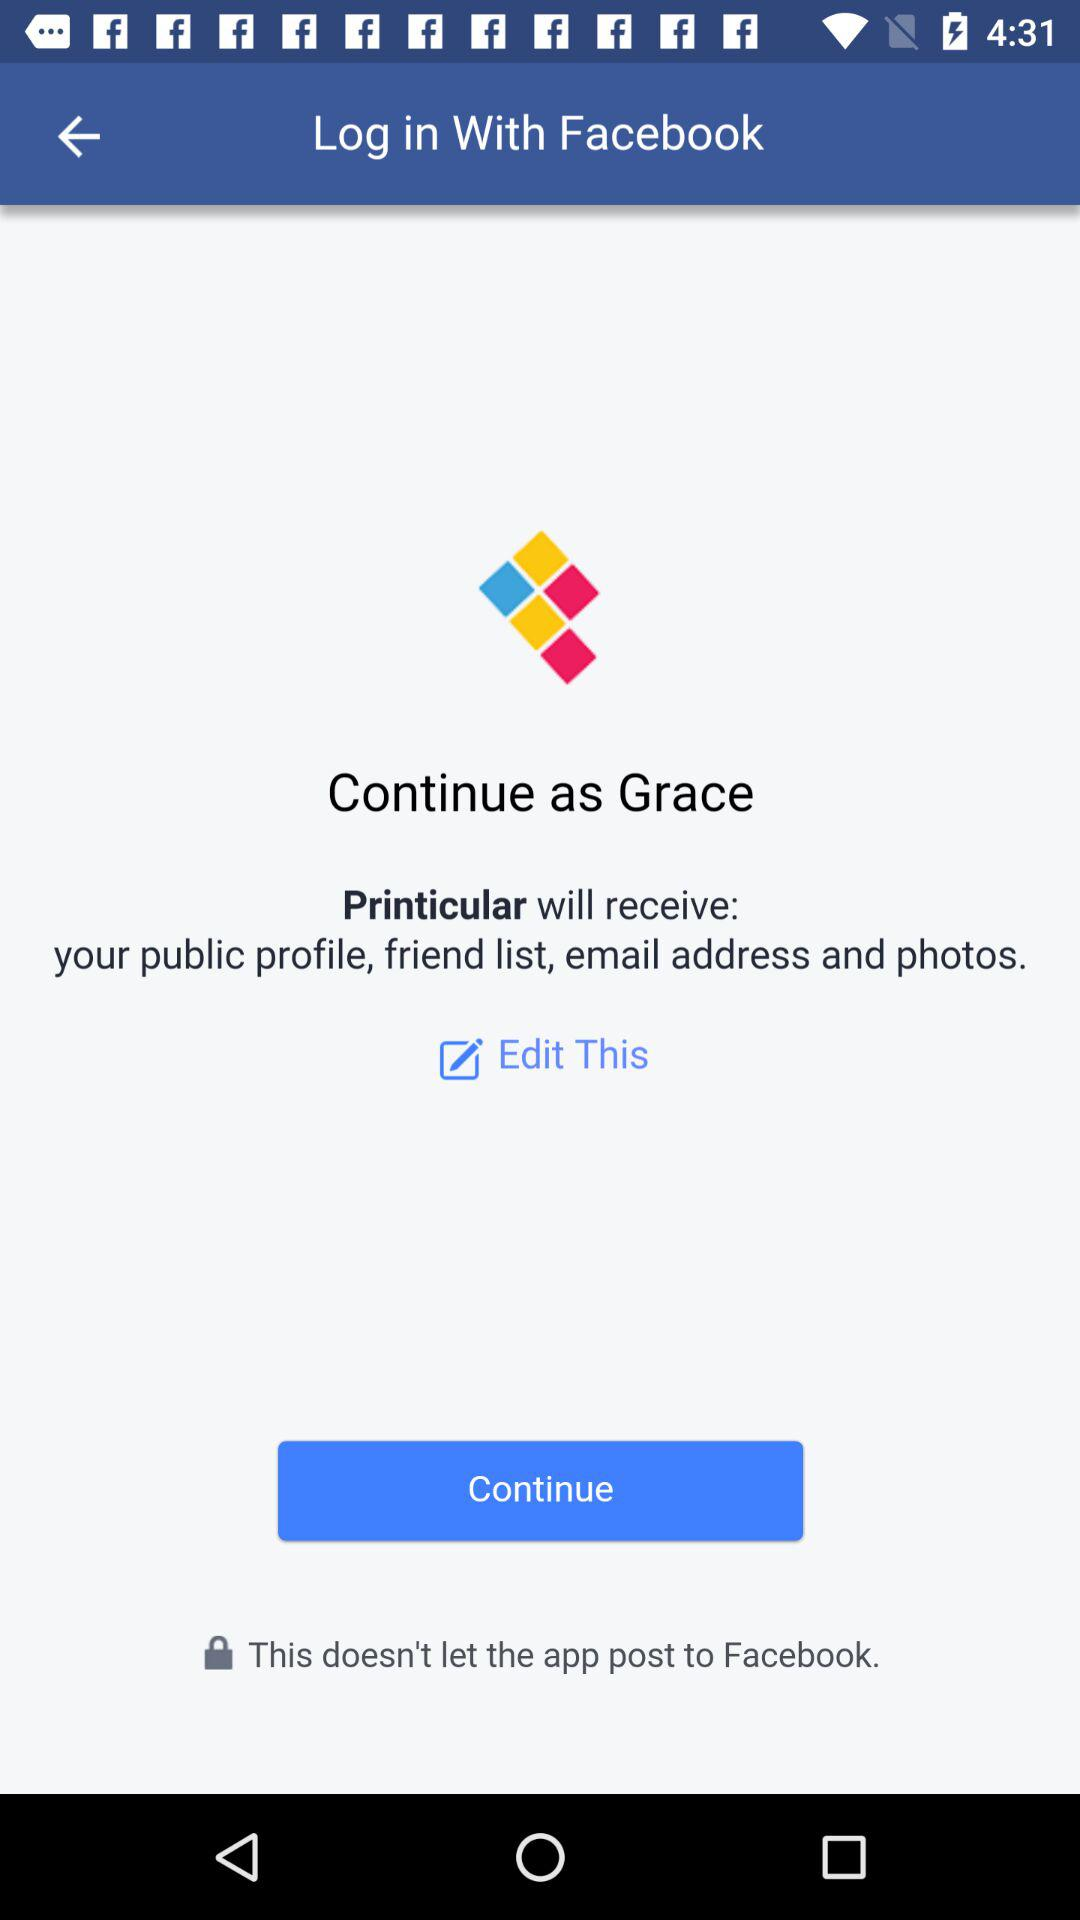What's the name of the user through which the application can be continued? The name of the user is "Grace". 